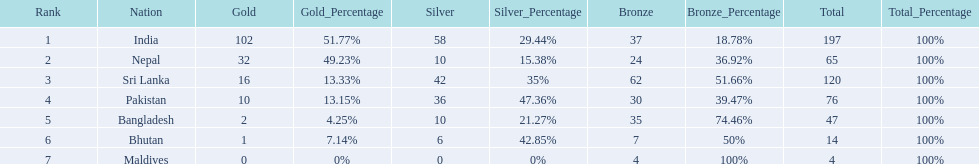How many gold medals were awarded between all 7 nations? 163. 